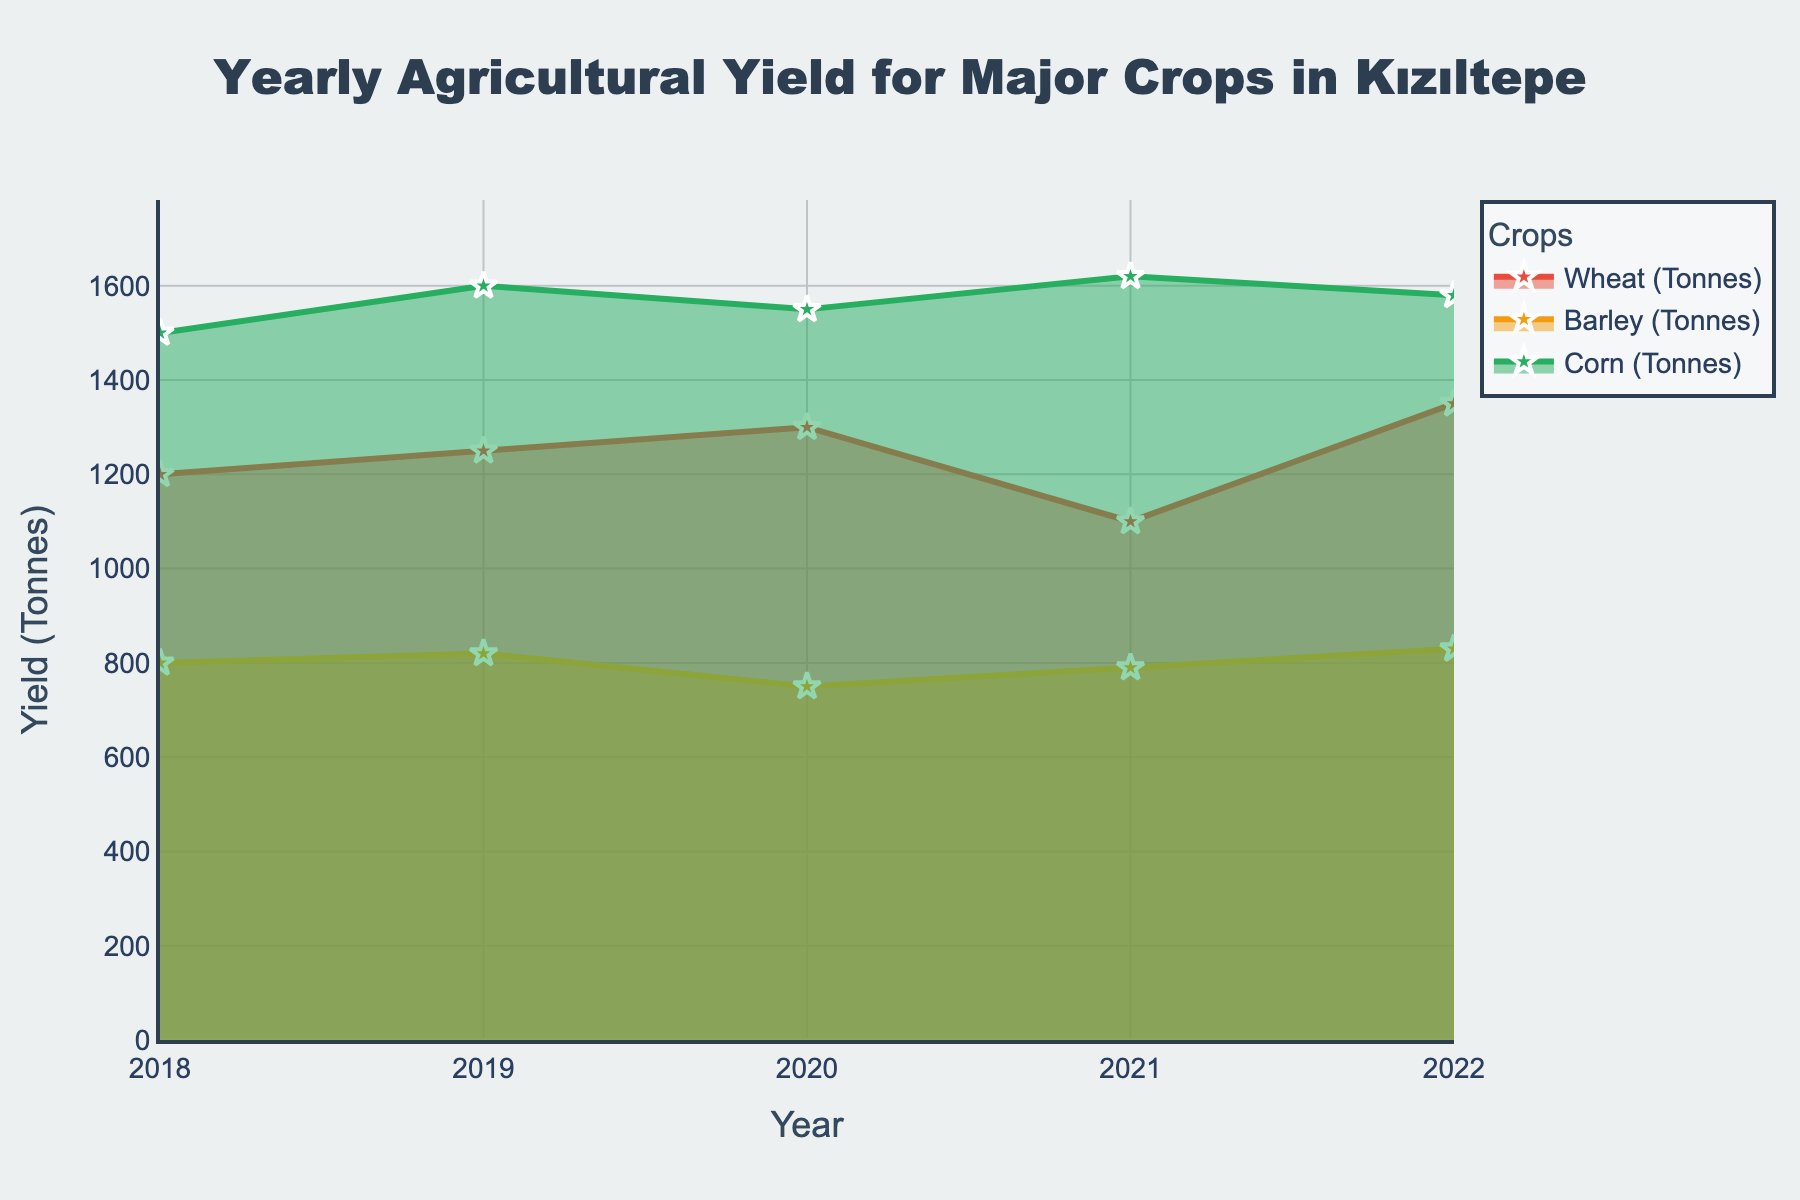How many years of data are shown in the plot? The plot displays data points for each year from 2018 to 2022, making it five years in total.
Answer: 5 Which crop has the highest yield in 2022? In 2022, the plot shows that Corn has the highest yield compared to Wheat and Barley.
Answer: Corn What is the overall trend for wheat yield from 2018 to 2022? Observing the Wheat yield line from 2018 to 2022, there is slight fluctuation but mainly an increasing trend, with a small dip in 2021.
Answer: Increasing What are the yields for Barley in 2018 and 2019, and what is the difference between these two values? According to the plot, Barley yield in 2018 is 800 tonnes and in 2019 is 820 tonnes. The difference is 820 - 800 = 20 tonnes.
Answer: 20 tonnes Compare the yield trends of Wheat and Corn. Which of the two shows more stability? Wheat yield shows more variability with a notable dip in 2021, whereas Corn yield consistently rises every year from 2018 to 2021 with a slight dip in 2022, making Corn more stable.
Answer: Corn What is the average yield for Corn over the displayed years? The Corn yields for each year from 2018 to 2022 are 1500, 1600, 1550, 1620, and 1580 tonnes, respectively. The average is calculated as (1500+1600+1550+1620+1580)/5 = 1570 tonnes.
Answer: 1570 tonnes Which year witnessed the lowest yield for any crop, and what was the yield? Observing the plot, the lowest yield was recorded for Wheat in 2021, with a yield of 1100 tonnes.
Answer: 1100 tonnes How do the yield trends for Barley and Wheat differ from 2019 to 2021? For Barley, the yields fluctuate slightly around 800 tonnes, while Wheat experiences a noticeable decrease from 1250 tonnes in 2019 to 1100 tonnes in 2021, showing a declining trend.
Answer: Barley - stable, Wheat - declining Between Wheat and Barley, which crop shows a greater fluctuation in yield over the years? Reviewing the plot, Wheat yield changes significantly over the years, including a marked drop in 2021, while Barley yield remains more stable. Thus, Wheat has greater fluctuation.
Answer: Wheat 